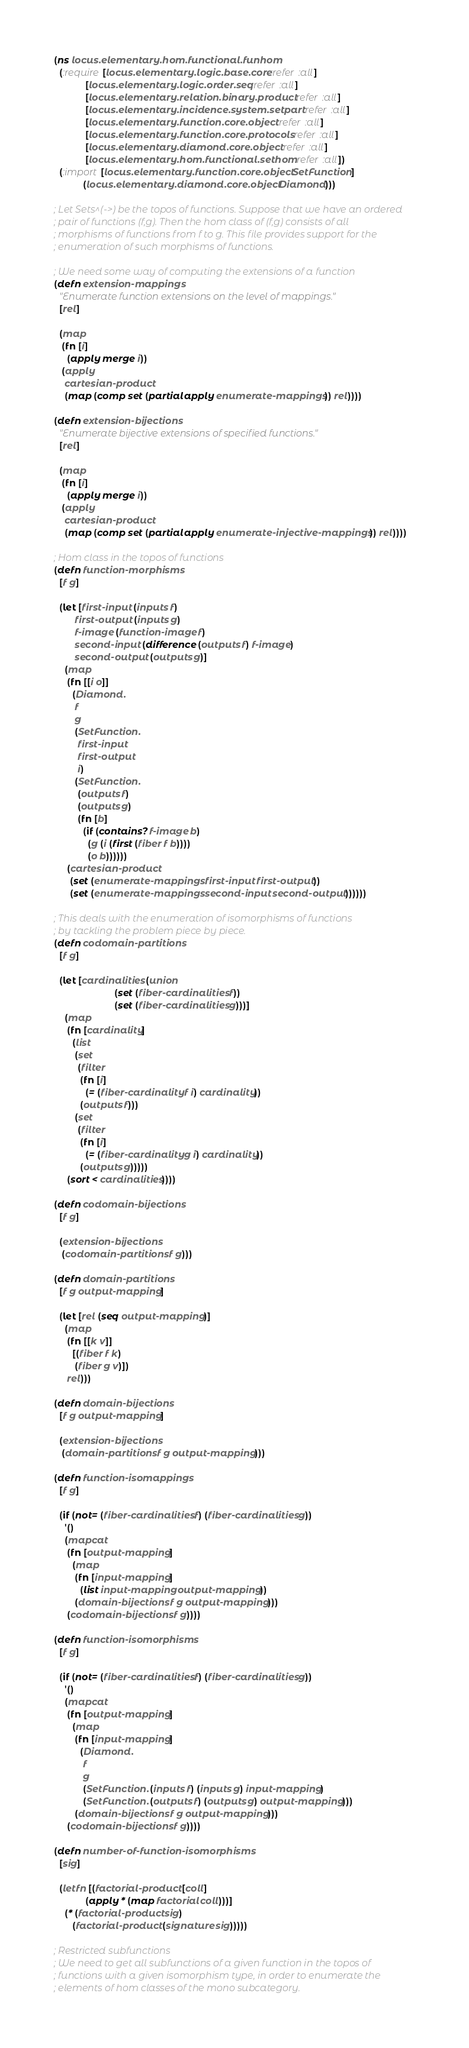Convert code to text. <code><loc_0><loc_0><loc_500><loc_500><_Clojure_>(ns locus.elementary.hom.functional.funhom
  (:require [locus.elementary.logic.base.core :refer :all]
            [locus.elementary.logic.order.seq :refer :all]
            [locus.elementary.relation.binary.product :refer :all]
            [locus.elementary.incidence.system.setpart :refer :all]
            [locus.elementary.function.core.object :refer :all]
            [locus.elementary.function.core.protocols :refer :all]
            [locus.elementary.diamond.core.object :refer :all]
            [locus.elementary.hom.functional.sethom :refer :all])
  (:import [locus.elementary.function.core.object SetFunction]
           (locus.elementary.diamond.core.object Diamond)))

; Let Sets^(->) be the topos of functions. Suppose that we have an ordered
; pair of functions (f,g). Then the hom class of (f,g) consists of all
; morphisms of functions from f to g. This file provides support for the
; enumeration of such morphisms of functions.

; We need some way of computing the extensions of a function
(defn extension-mappings
  "Enumerate function extensions on the level of mappings."
  [rel]

  (map
   (fn [i]
     (apply merge i))
   (apply
    cartesian-product
    (map (comp set (partial apply enumerate-mappings)) rel))))

(defn extension-bijections
  "Enumerate bijective extensions of specified functions."
  [rel]

  (map
   (fn [i]
     (apply merge i))
   (apply
    cartesian-product
    (map (comp set (partial apply enumerate-injective-mappings)) rel))))

; Hom class in the topos of functions
(defn function-morphisms
  [f g]

  (let [first-input (inputs f)
        first-output (inputs g)
        f-image (function-image f)
        second-input (difference (outputs f) f-image)
        second-output (outputs g)]
    (map
     (fn [[i o]]
       (Diamond.
        f
        g
        (SetFunction.
         first-input
         first-output
         i)
        (SetFunction.
         (outputs f)
         (outputs g)
         (fn [b]
           (if (contains? f-image b)
             (g (i (first (fiber f b))))
             (o b))))))
     (cartesian-product
      (set (enumerate-mappings first-input first-output))
      (set (enumerate-mappings second-input second-output))))))

; This deals with the enumeration of isomorphisms of functions
; by tackling the problem piece by piece.
(defn codomain-partitions
  [f g]

  (let [cardinalities (union
                       (set (fiber-cardinalities f))
                       (set (fiber-cardinalities g)))]
    (map
     (fn [cardinality]
       (list
        (set
         (filter
          (fn [i]
            (= (fiber-cardinality f i) cardinality))
          (outputs f)))
        (set
         (filter
          (fn [i]
            (= (fiber-cardinality g i) cardinality))
          (outputs g)))))
     (sort < cardinalities))))

(defn codomain-bijections
  [f g]

  (extension-bijections
   (codomain-partitions f g)))

(defn domain-partitions
  [f g output-mapping]

  (let [rel (seq output-mapping)]
    (map
     (fn [[k v]]
       [(fiber f k)
        (fiber g v)])
     rel)))

(defn domain-bijections
  [f g output-mapping]

  (extension-bijections
   (domain-partitions f g output-mapping)))

(defn function-isomappings
  [f g]

  (if (not= (fiber-cardinalities f) (fiber-cardinalities g))
    '()
    (mapcat
     (fn [output-mapping]
       (map
        (fn [input-mapping]
          (list input-mapping output-mapping))
        (domain-bijections f g output-mapping)))
     (codomain-bijections f g))))

(defn function-isomorphisms
  [f g]

  (if (not= (fiber-cardinalities f) (fiber-cardinalities g))
    '()
    (mapcat
     (fn [output-mapping]
       (map
        (fn [input-mapping]
          (Diamond.
           f
           g
           (SetFunction. (inputs f) (inputs g) input-mapping)
           (SetFunction. (outputs f) (outputs g) output-mapping)))
        (domain-bijections f g output-mapping)))
     (codomain-bijections f g))))

(defn number-of-function-isomorphisms
  [sig]

  (letfn [(factorial-product [coll]
            (apply * (map factorial coll)))]
    (* (factorial-product sig)
       (factorial-product (signature sig)))))

; Restricted subfunctions 
; We need to get all subfunctions of a given function in the topos of 
; functions with a given isomorphism type, in order to enumerate the
; elements of hom classes of the mono subcategory.</code> 